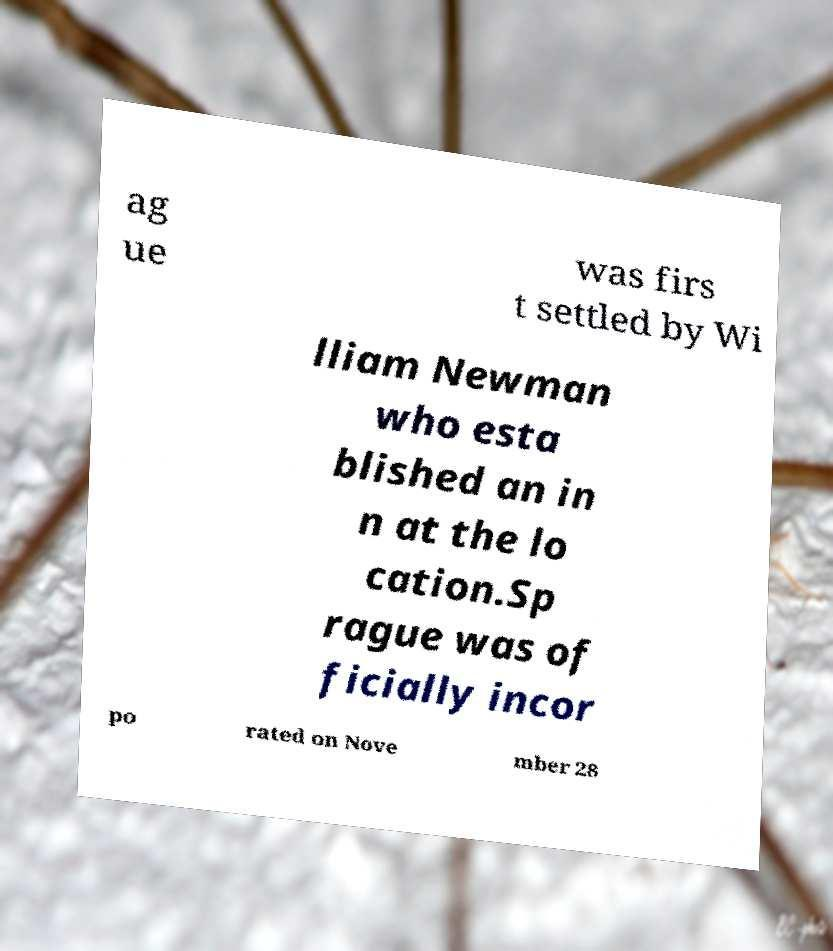Please identify and transcribe the text found in this image. ag ue was firs t settled by Wi lliam Newman who esta blished an in n at the lo cation.Sp rague was of ficially incor po rated on Nove mber 28 